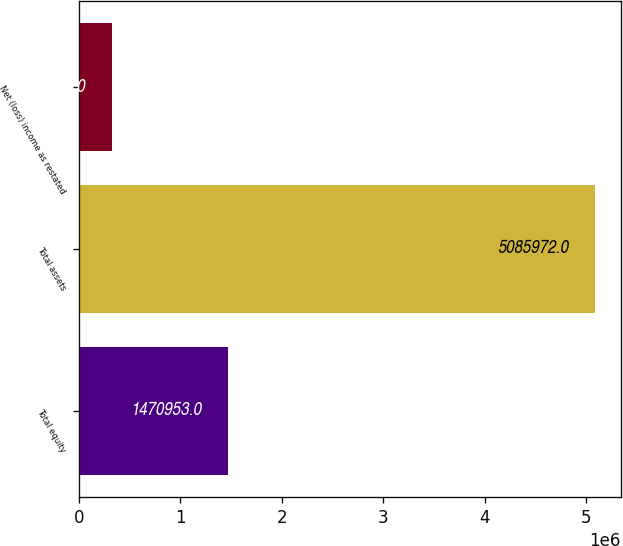Convert chart to OTSL. <chart><loc_0><loc_0><loc_500><loc_500><bar_chart><fcel>Total equity<fcel>Total assets<fcel>Net (loss) income as restated<nl><fcel>1.47095e+06<fcel>5.08597e+06<fcel>325321<nl></chart> 